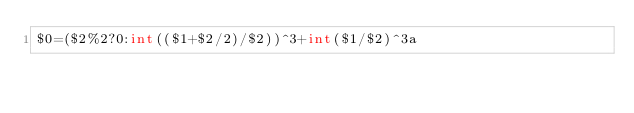<code> <loc_0><loc_0><loc_500><loc_500><_Awk_>$0=($2%2?0:int(($1+$2/2)/$2))^3+int($1/$2)^3a</code> 